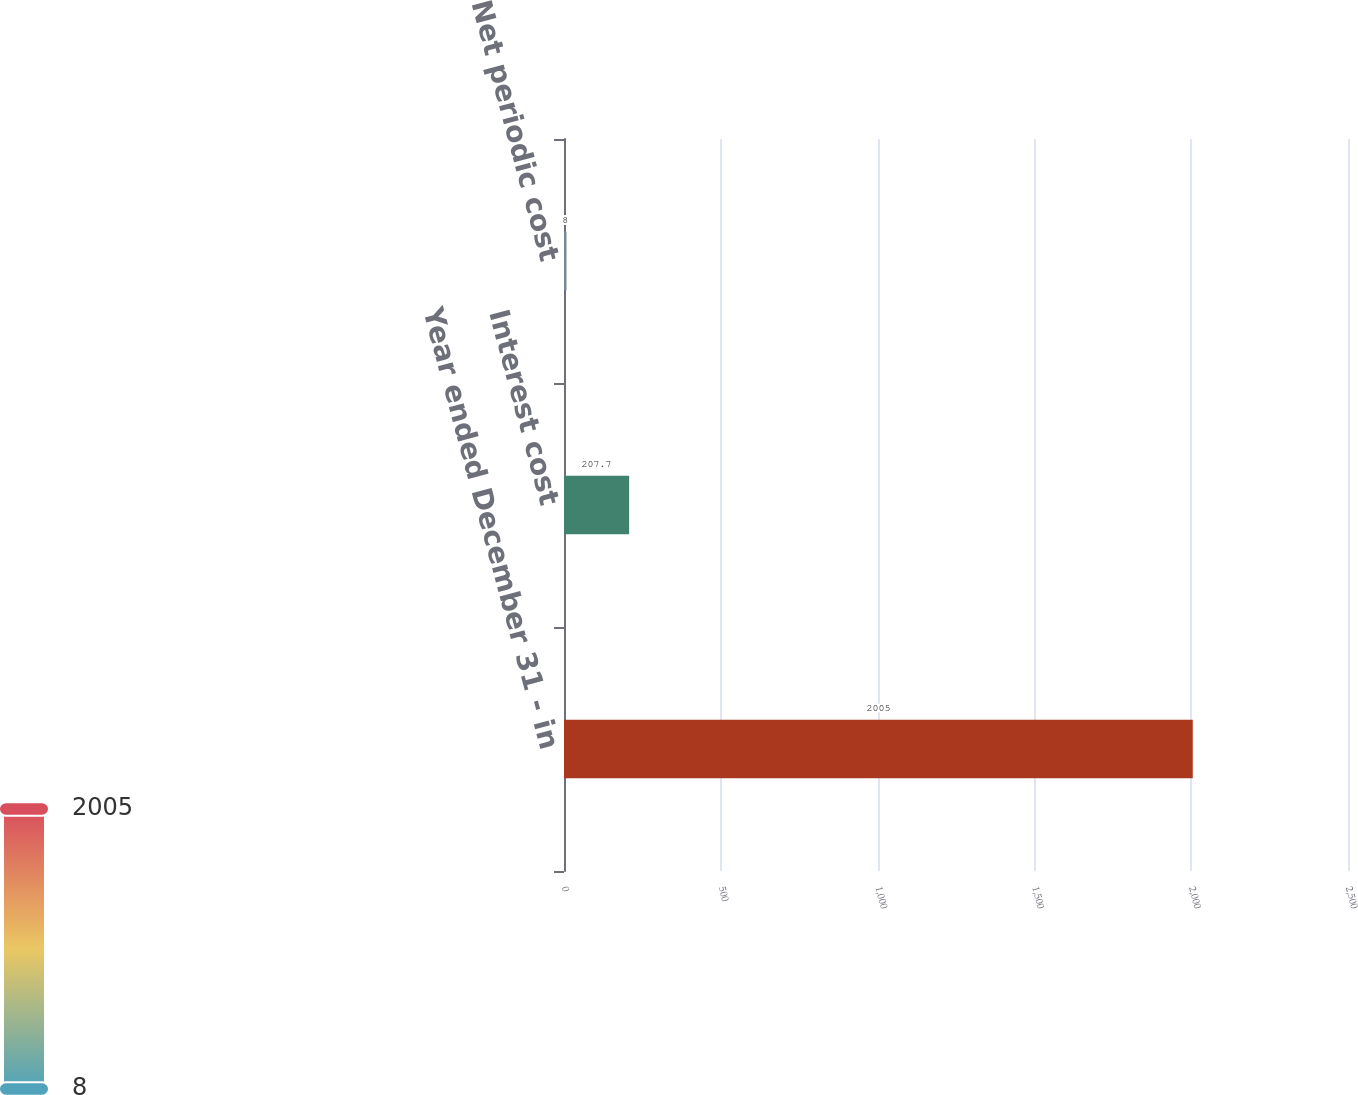<chart> <loc_0><loc_0><loc_500><loc_500><bar_chart><fcel>Year ended December 31 - in<fcel>Interest cost<fcel>Net periodic cost<nl><fcel>2005<fcel>207.7<fcel>8<nl></chart> 